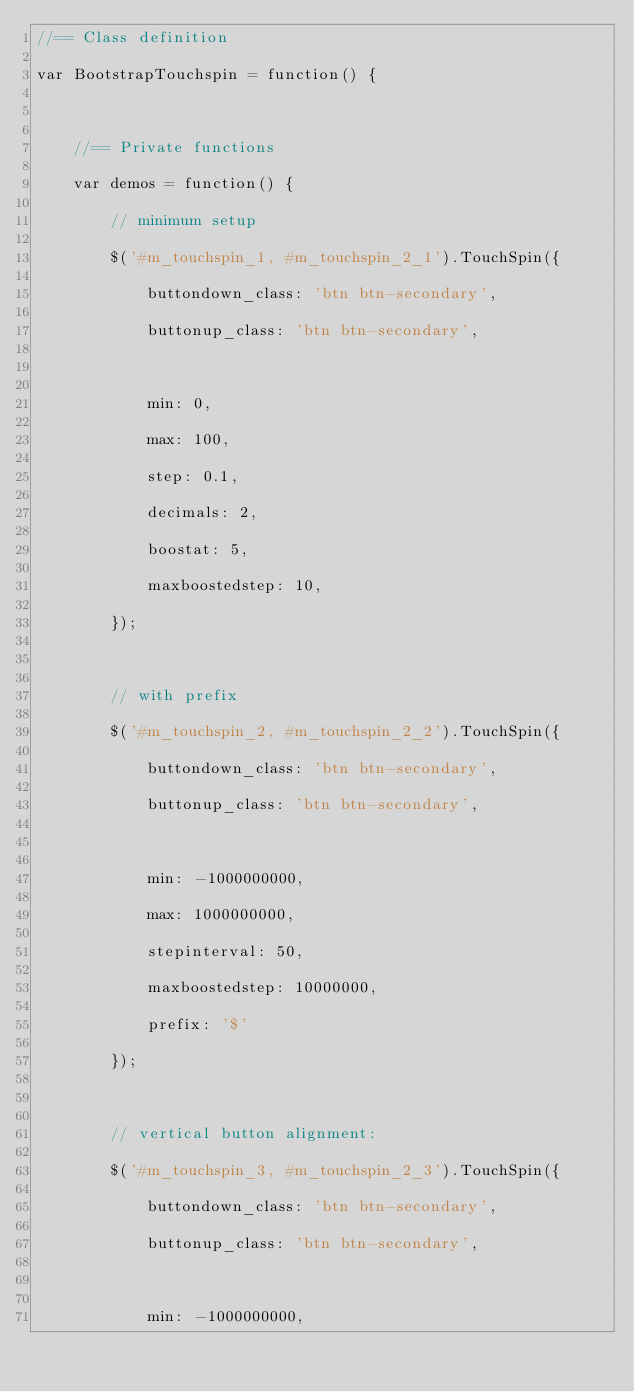<code> <loc_0><loc_0><loc_500><loc_500><_JavaScript_>//== Class definition
var BootstrapTouchspin = function() {

    //== Private functions
    var demos = function() {
        // minimum setup
        $('#m_touchspin_1, #m_touchspin_2_1').TouchSpin({
            buttondown_class: 'btn btn-secondary',
            buttonup_class: 'btn btn-secondary',

            min: 0,
            max: 100,
            step: 0.1,
            decimals: 2,
            boostat: 5,
            maxboostedstep: 10,
        });

        // with prefix
        $('#m_touchspin_2, #m_touchspin_2_2').TouchSpin({
            buttondown_class: 'btn btn-secondary',
            buttonup_class: 'btn btn-secondary',

            min: -1000000000,
            max: 1000000000,
            stepinterval: 50,
            maxboostedstep: 10000000,
            prefix: '$'
        });

        // vertical button alignment:
        $('#m_touchspin_3, #m_touchspin_2_3').TouchSpin({
            buttondown_class: 'btn btn-secondary',
            buttonup_class: 'btn btn-secondary',

            min: -1000000000,</code> 